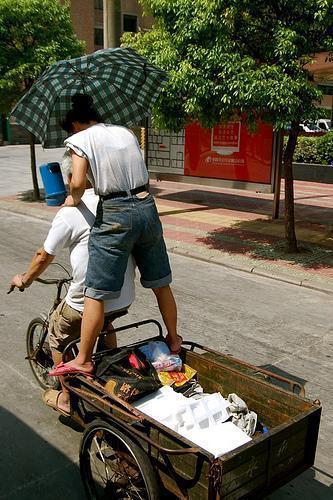How many people are in the photo?
Give a very brief answer. 2. 